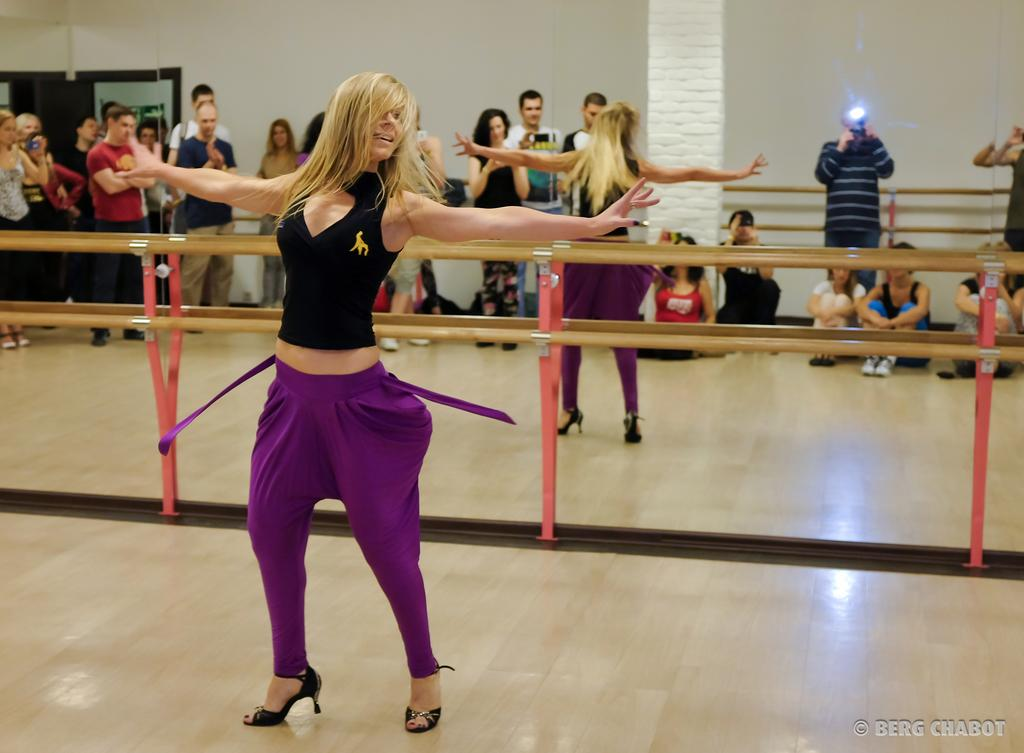What can be seen in the image related to people? There are persons wearing clothes in the image. What is located in the middle of the image? There are safety grills in the middle of the image. What is visible at the top of the image? There is a wall at the top of the image. How many stitches are visible on the clothes of the persons in the image? There is no information about the number of stitches on the clothes of the persons in the image. What type of truck can be seen in the image? There is no truck present in the image. 